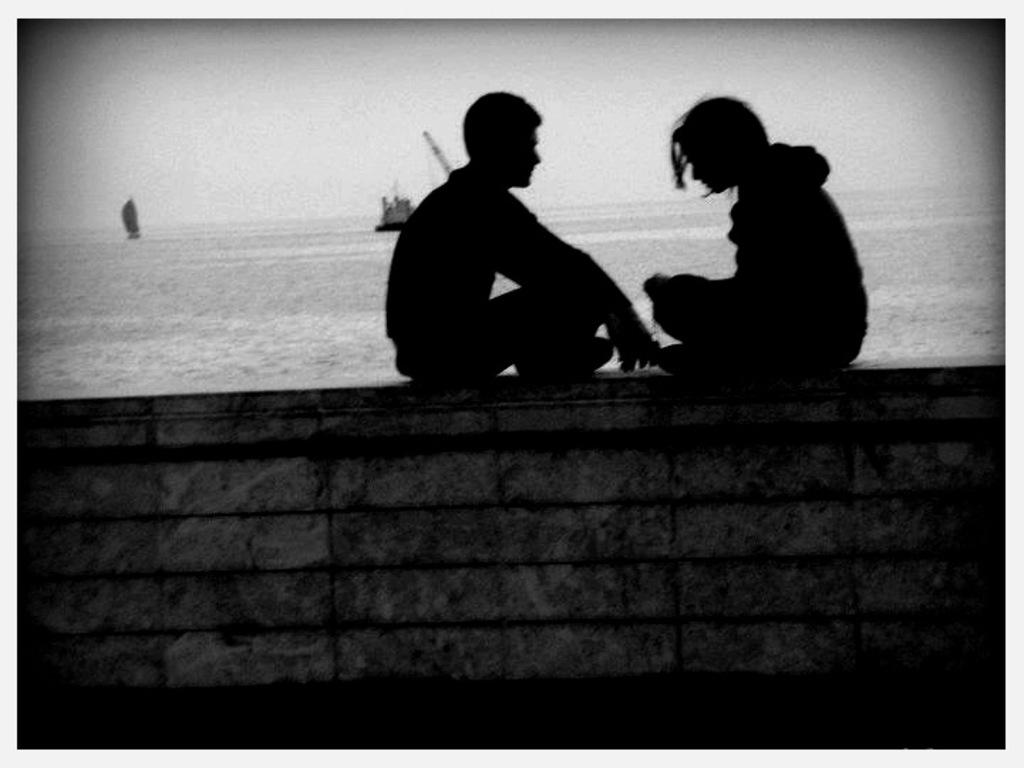What are the two people in the image doing? The two people are sitting on a wall in the image. What can be seen in the background of the image? Boats, water, and the sky are visible in the background of the image. What is the color scheme of the image? The image is black and white in color. What type of country is depicted in the image? The image does not depict a country; it is a scene with two people sitting on a wall and a background featuring boats, water, and the sky. What kind of apparel are the people wearing in the image? The image is black and white, so it is difficult to determine the specific apparel worn by the people in the image. 